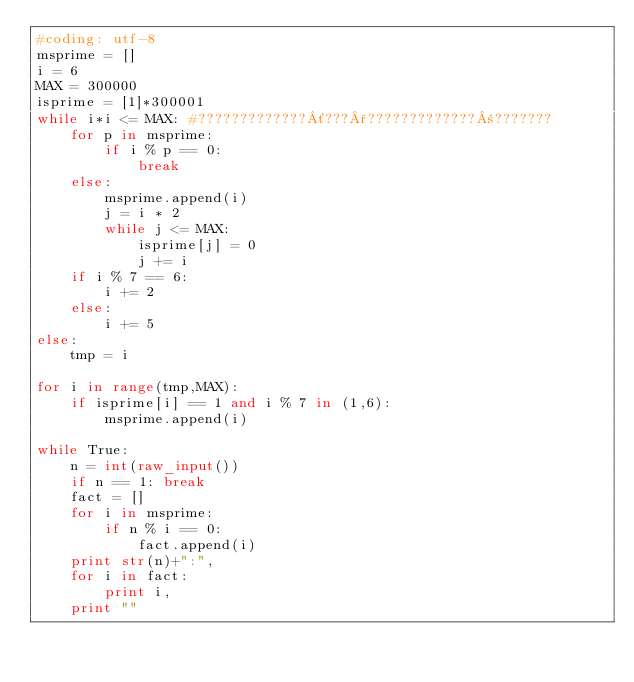Convert code to text. <code><loc_0><loc_0><loc_500><loc_500><_Python_>#coding: utf-8
msprime = []
i = 6
MAX = 300000
isprime = [1]*300001
while i*i <= MAX: #?????????????´???°?????????????±???????
    for p in msprime:
        if i % p == 0:
            break
    else:
        msprime.append(i)
        j = i * 2
        while j <= MAX:
            isprime[j] = 0
            j += i
    if i % 7 == 6:
        i += 2
    else:
        i += 5
else:
    tmp = i

for i in range(tmp,MAX):
    if isprime[i] == 1 and i % 7 in (1,6):
        msprime.append(i)

while True:
    n = int(raw_input())
    if n == 1: break
    fact = []
    for i in msprime:
        if n % i == 0:
            fact.append(i)
    print str(n)+":",
    for i in fact:
        print i,
    print ""</code> 